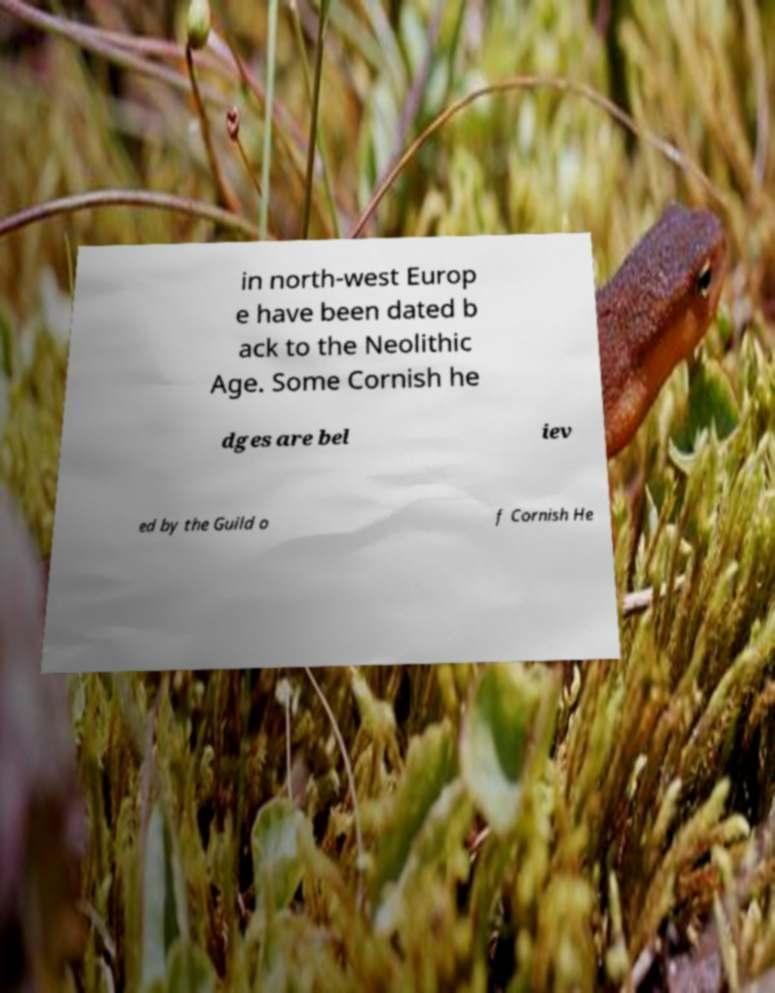Could you extract and type out the text from this image? in north-west Europ e have been dated b ack to the Neolithic Age. Some Cornish he dges are bel iev ed by the Guild o f Cornish He 